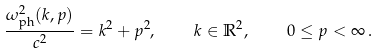<formula> <loc_0><loc_0><loc_500><loc_500>\frac { \omega _ { \text {ph} } ^ { 2 } ( k , p ) } { c ^ { 2 } } = k ^ { 2 } + p ^ { 2 } , \quad k \in \mathbb { R } ^ { 2 } , \quad 0 \leq p < \infty \, { . }</formula> 